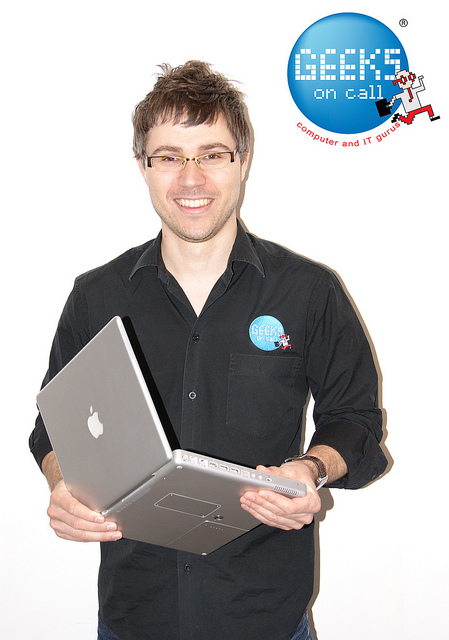Please transcribe the text information in this image. GEEKS on call computer Burus 